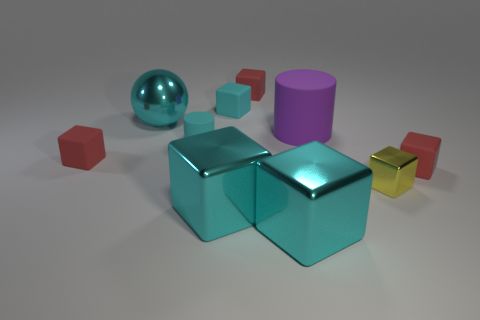Are there any other things that have the same color as the ball?
Offer a terse response. Yes. Is the large sphere the same color as the tiny cylinder?
Give a very brief answer. Yes. What is the shape of the small thing that is the same color as the small matte cylinder?
Make the answer very short. Cube. Does the small cyan cylinder have the same material as the large cyan ball?
Your response must be concise. No. How many metallic things are either cyan objects or big cyan cubes?
Provide a succinct answer. 3. There is a cyan rubber thing that is in front of the large matte thing; what shape is it?
Make the answer very short. Cylinder. What is the size of the other cylinder that is made of the same material as the small cyan cylinder?
Your response must be concise. Large. The big object that is to the right of the small cyan cube and in front of the small metallic object has what shape?
Offer a very short reply. Cube. Does the metallic thing that is to the left of the cyan rubber cylinder have the same color as the small cylinder?
Your answer should be very brief. Yes. There is a matte object on the right side of the small yellow cube; does it have the same shape as the small yellow object that is in front of the cyan ball?
Your answer should be very brief. Yes. 